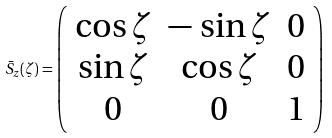<formula> <loc_0><loc_0><loc_500><loc_500>\bar { S } _ { z } ( \zeta ) = \left ( \begin{array} { c c c } \cos \zeta & - \, \sin \zeta & 0 \\ \sin \zeta & \cos \zeta & 0 \\ 0 & 0 & 1 \end{array} \right )</formula> 